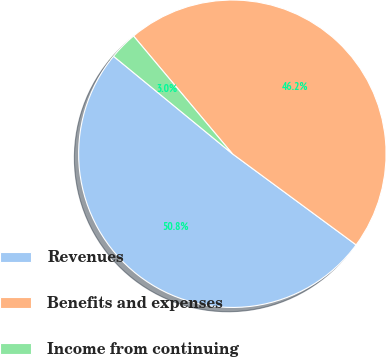Convert chart to OTSL. <chart><loc_0><loc_0><loc_500><loc_500><pie_chart><fcel>Revenues<fcel>Benefits and expenses<fcel>Income from continuing<nl><fcel>50.83%<fcel>46.21%<fcel>2.95%<nl></chart> 